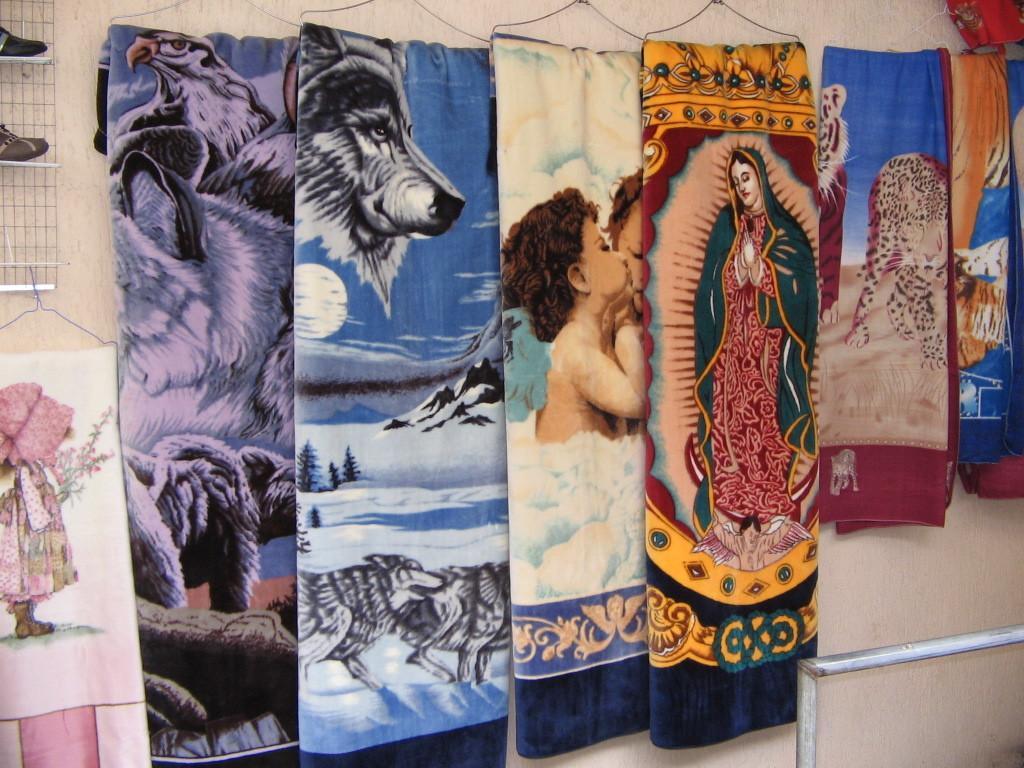In one or two sentences, can you explain what this image depicts? In this image there are a few blankets with different prints on them are hanged to the hanger on the wall. 